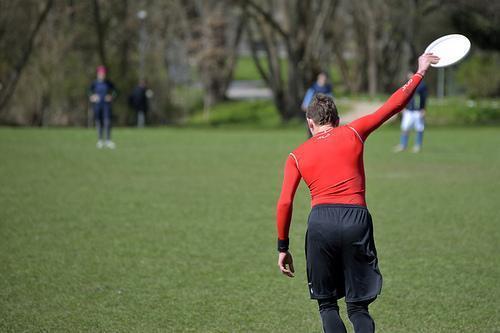How many people are there in red shirts?
Give a very brief answer. 1. 